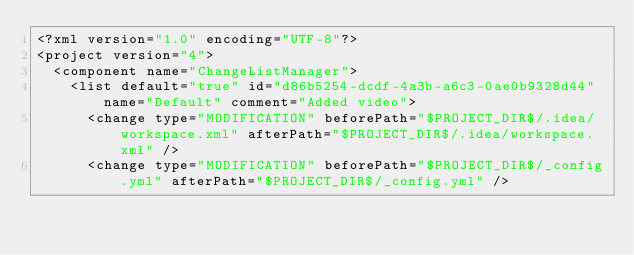<code> <loc_0><loc_0><loc_500><loc_500><_XML_><?xml version="1.0" encoding="UTF-8"?>
<project version="4">
  <component name="ChangeListManager">
    <list default="true" id="d86b5254-dcdf-4a3b-a6c3-0ae0b9328d44" name="Default" comment="Added video">
      <change type="MODIFICATION" beforePath="$PROJECT_DIR$/.idea/workspace.xml" afterPath="$PROJECT_DIR$/.idea/workspace.xml" />
      <change type="MODIFICATION" beforePath="$PROJECT_DIR$/_config.yml" afterPath="$PROJECT_DIR$/_config.yml" /></code> 